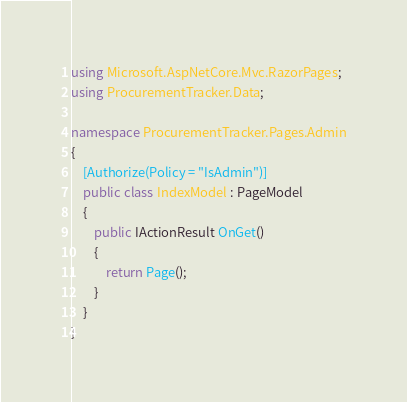Convert code to text. <code><loc_0><loc_0><loc_500><loc_500><_C#_>using Microsoft.AspNetCore.Mvc.RazorPages;
using ProcurementTracker.Data;

namespace ProcurementTracker.Pages.Admin
{
	[Authorize(Policy = "IsAdmin")]
	public class IndexModel : PageModel
    {
        public IActionResult OnGet()
        {
            return Page();
        }
    }
}</code> 